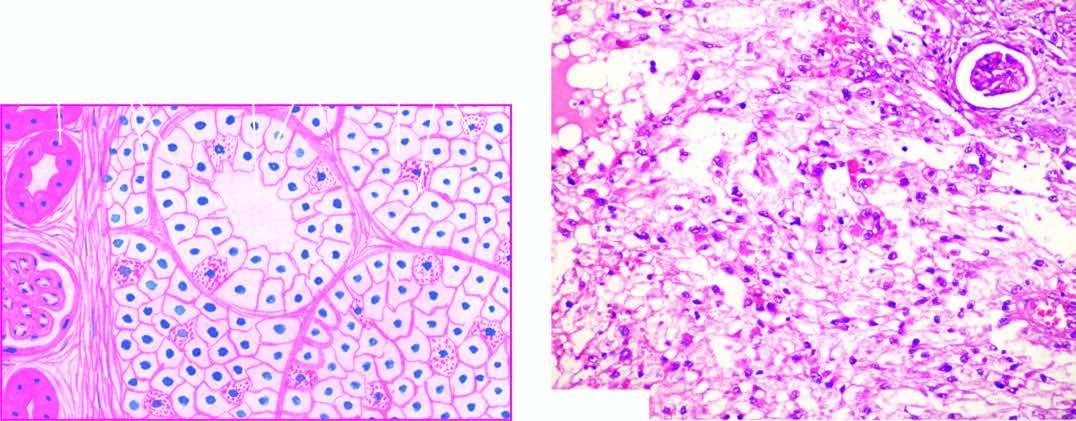what is composed of fine and delicate fibrous tissue?
Answer the question using a single word or phrase. Stroma 